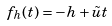Convert formula to latex. <formula><loc_0><loc_0><loc_500><loc_500>f _ { h } ( t ) = - h + \tilde { u } t</formula> 